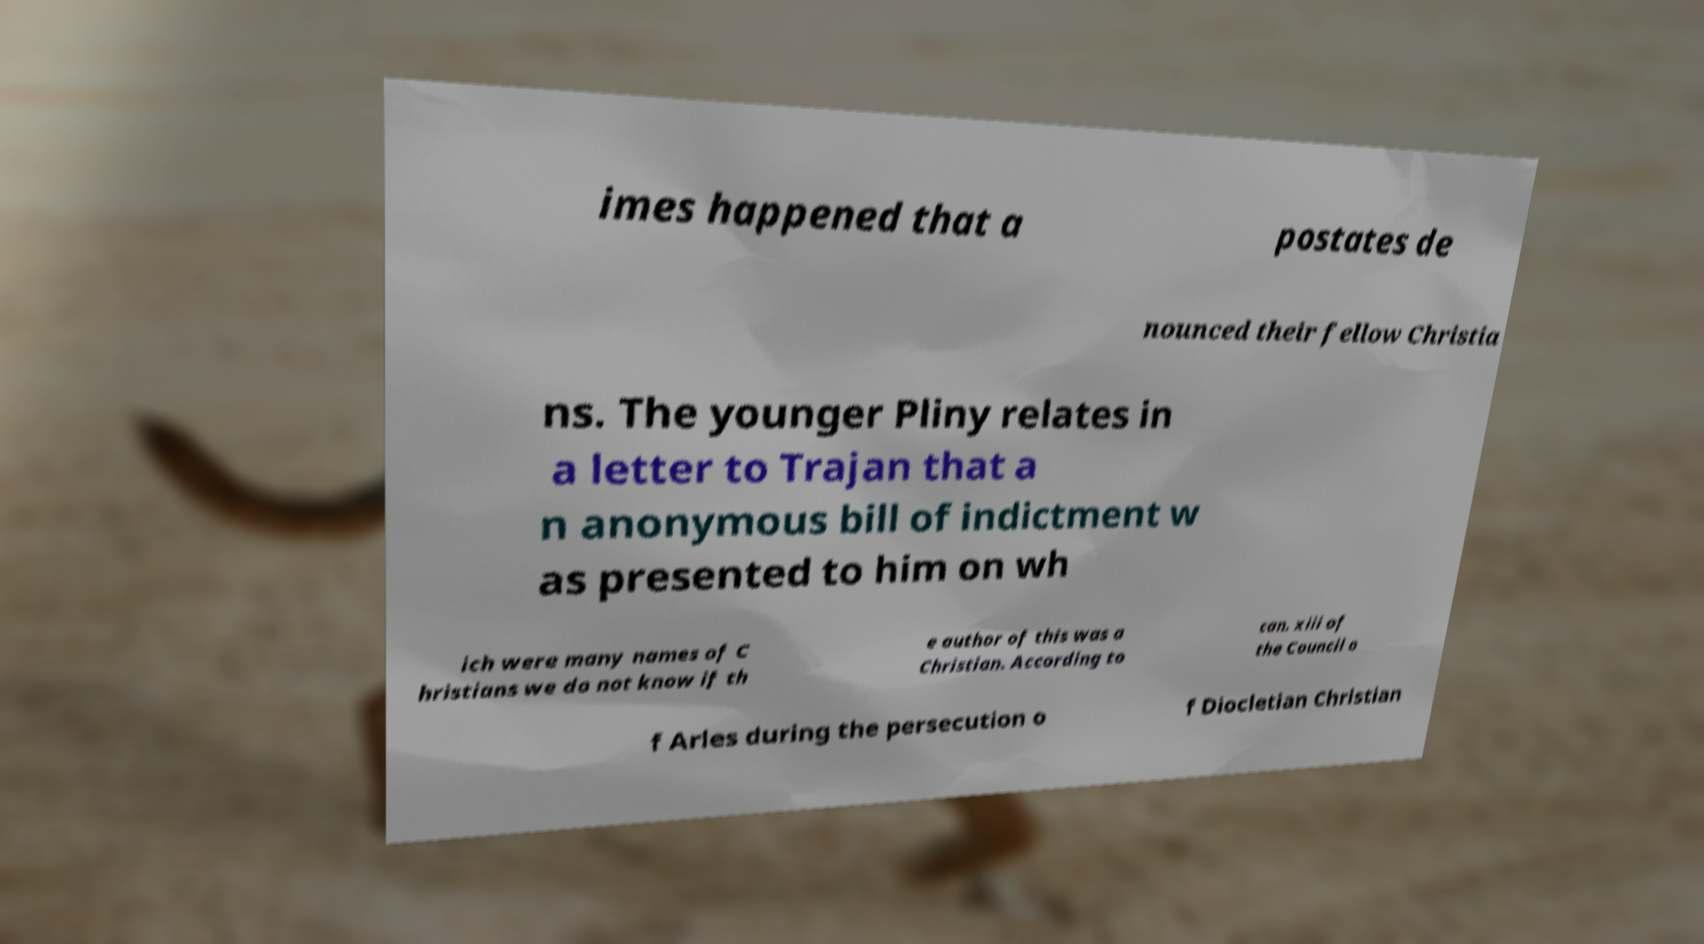What messages or text are displayed in this image? I need them in a readable, typed format. imes happened that a postates de nounced their fellow Christia ns. The younger Pliny relates in a letter to Trajan that a n anonymous bill of indictment w as presented to him on wh ich were many names of C hristians we do not know if th e author of this was a Christian. According to can. xiii of the Council o f Arles during the persecution o f Diocletian Christian 